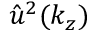<formula> <loc_0><loc_0><loc_500><loc_500>\hat { u } ^ { 2 } ( k _ { z } )</formula> 